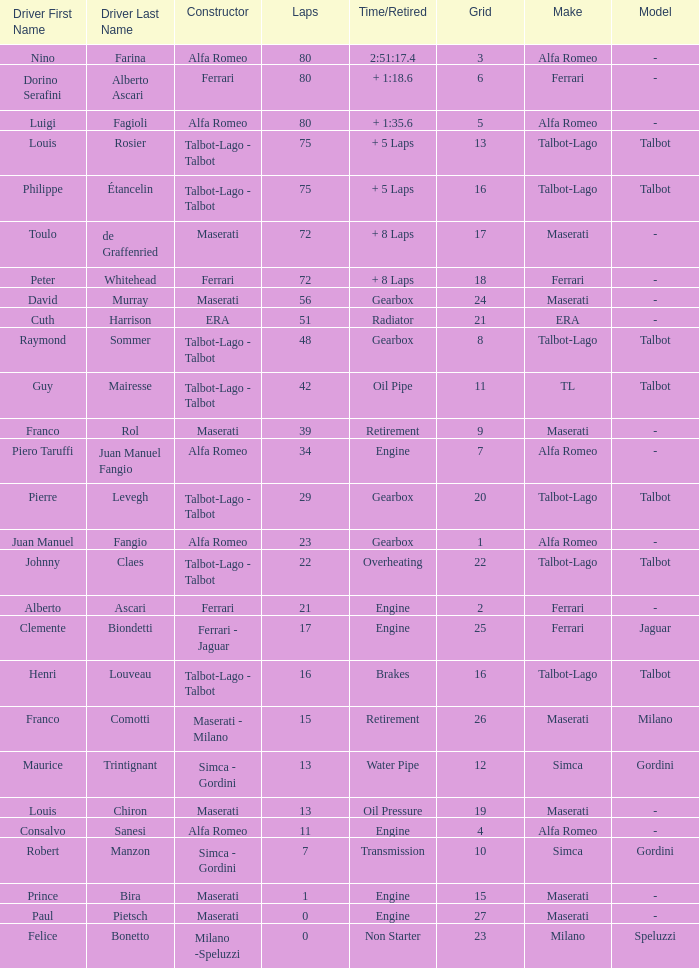When grid is less than 7, laps are greater than 17, and time/retired is + 1:35.6, who is the constructor? Alfa Romeo. 